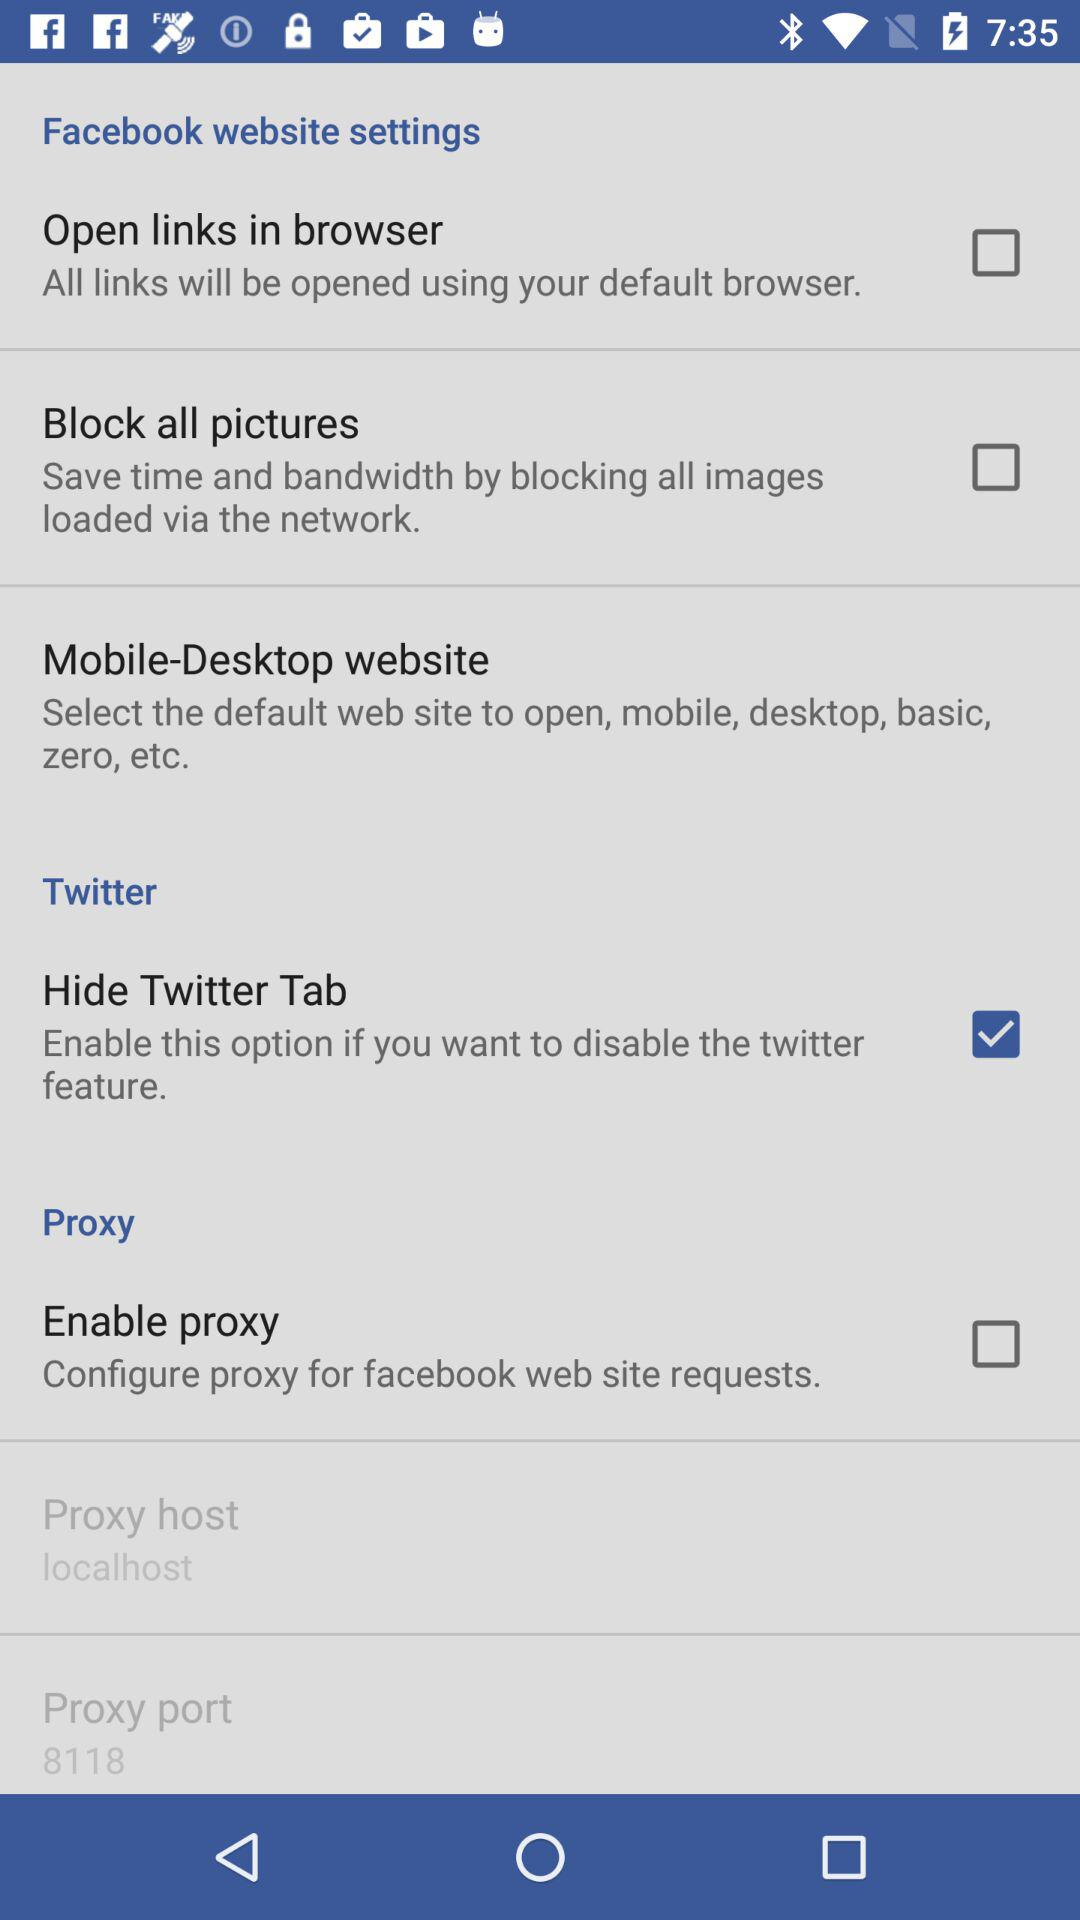How many items are in the "Proxy" section?
Answer the question using a single word or phrase. 3 